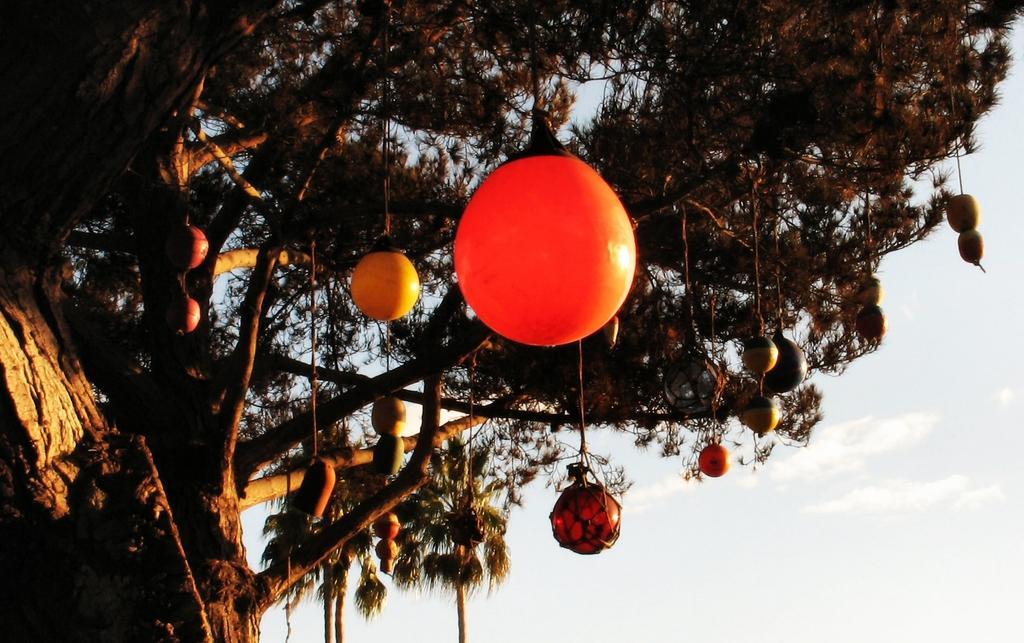Could you give a brief overview of what you see in this image? In this image we can see some objects hanged to a tree which are tied with the ropes. On the backside we can see some trees and the sky which looks cloudy. 